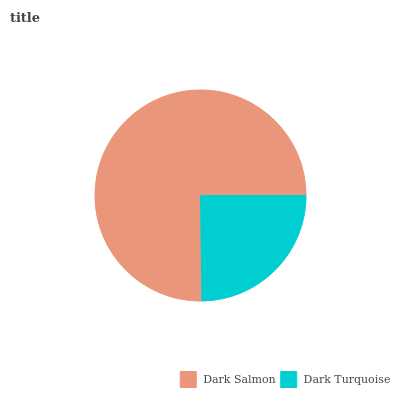Is Dark Turquoise the minimum?
Answer yes or no. Yes. Is Dark Salmon the maximum?
Answer yes or no. Yes. Is Dark Turquoise the maximum?
Answer yes or no. No. Is Dark Salmon greater than Dark Turquoise?
Answer yes or no. Yes. Is Dark Turquoise less than Dark Salmon?
Answer yes or no. Yes. Is Dark Turquoise greater than Dark Salmon?
Answer yes or no. No. Is Dark Salmon less than Dark Turquoise?
Answer yes or no. No. Is Dark Salmon the high median?
Answer yes or no. Yes. Is Dark Turquoise the low median?
Answer yes or no. Yes. Is Dark Turquoise the high median?
Answer yes or no. No. Is Dark Salmon the low median?
Answer yes or no. No. 